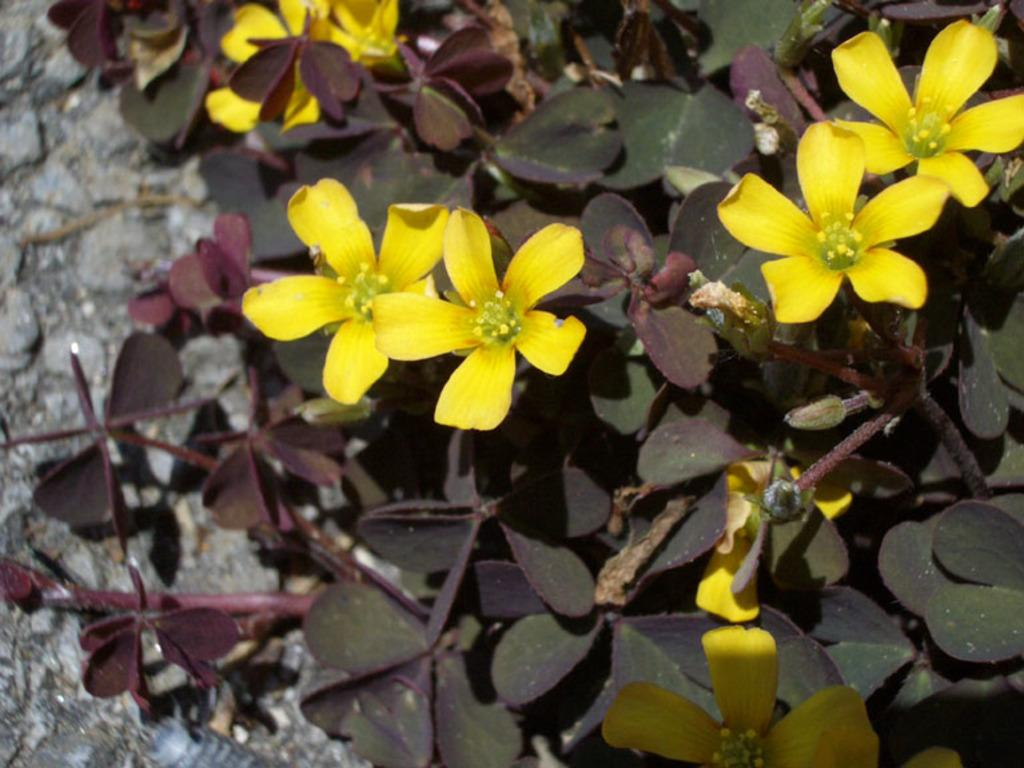What types of living organisms are in the foreground of the image? There are plants and flowers in the foreground of the image. Can you describe the plants and flowers in the foreground? The plants and flowers are located in the foreground of the image. What is visible in the background of the image? There is a wall in the background of the image. What type of cheese is being photographed by the camera in the image? There is no cheese or camera present in the image. 